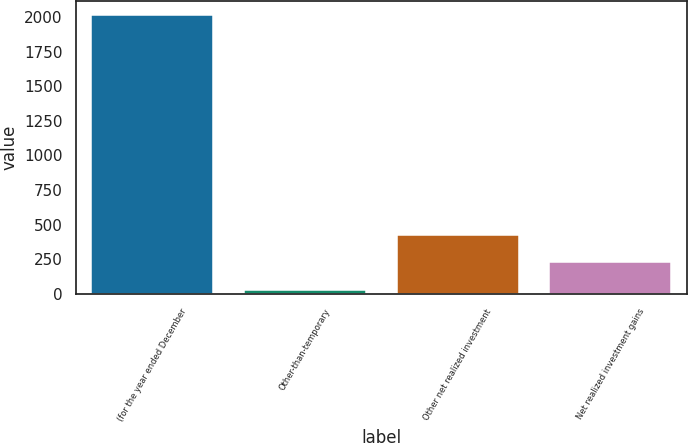Convert chart to OTSL. <chart><loc_0><loc_0><loc_500><loc_500><bar_chart><fcel>(for the year ended December<fcel>Other-than-temporary<fcel>Other net realized investment<fcel>Net realized investment gains<nl><fcel>2016<fcel>29<fcel>426.4<fcel>227.7<nl></chart> 